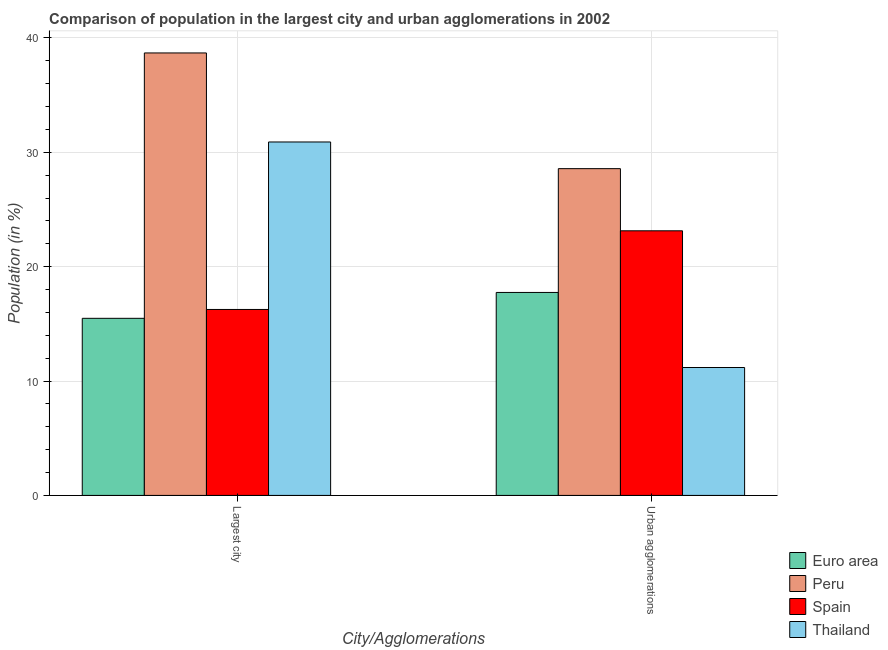How many groups of bars are there?
Offer a very short reply. 2. Are the number of bars per tick equal to the number of legend labels?
Offer a terse response. Yes. How many bars are there on the 1st tick from the left?
Provide a short and direct response. 4. What is the label of the 1st group of bars from the left?
Ensure brevity in your answer.  Largest city. What is the population in urban agglomerations in Thailand?
Give a very brief answer. 11.18. Across all countries, what is the maximum population in the largest city?
Offer a terse response. 38.68. Across all countries, what is the minimum population in the largest city?
Offer a terse response. 15.48. In which country was the population in the largest city maximum?
Keep it short and to the point. Peru. In which country was the population in urban agglomerations minimum?
Offer a terse response. Thailand. What is the total population in urban agglomerations in the graph?
Offer a terse response. 80.63. What is the difference between the population in the largest city in Peru and that in Thailand?
Provide a short and direct response. 7.78. What is the difference between the population in the largest city in Peru and the population in urban agglomerations in Euro area?
Give a very brief answer. 20.94. What is the average population in urban agglomerations per country?
Your answer should be very brief. 20.16. What is the difference between the population in urban agglomerations and population in the largest city in Euro area?
Provide a short and direct response. 2.26. In how many countries, is the population in urban agglomerations greater than 4 %?
Your answer should be very brief. 4. What is the ratio of the population in urban agglomerations in Peru to that in Spain?
Provide a short and direct response. 1.23. In how many countries, is the population in the largest city greater than the average population in the largest city taken over all countries?
Ensure brevity in your answer.  2. How many bars are there?
Make the answer very short. 8. Are the values on the major ticks of Y-axis written in scientific E-notation?
Provide a short and direct response. No. Does the graph contain any zero values?
Your answer should be very brief. No. How many legend labels are there?
Offer a terse response. 4. What is the title of the graph?
Your answer should be compact. Comparison of population in the largest city and urban agglomerations in 2002. Does "Oman" appear as one of the legend labels in the graph?
Offer a terse response. No. What is the label or title of the X-axis?
Your response must be concise. City/Agglomerations. What is the label or title of the Y-axis?
Keep it short and to the point. Population (in %). What is the Population (in %) of Euro area in Largest city?
Make the answer very short. 15.48. What is the Population (in %) of Peru in Largest city?
Ensure brevity in your answer.  38.68. What is the Population (in %) in Spain in Largest city?
Ensure brevity in your answer.  16.26. What is the Population (in %) of Thailand in Largest city?
Your response must be concise. 30.9. What is the Population (in %) in Euro area in Urban agglomerations?
Your response must be concise. 17.74. What is the Population (in %) in Peru in Urban agglomerations?
Keep it short and to the point. 28.57. What is the Population (in %) of Spain in Urban agglomerations?
Make the answer very short. 23.13. What is the Population (in %) of Thailand in Urban agglomerations?
Your response must be concise. 11.18. Across all City/Agglomerations, what is the maximum Population (in %) in Euro area?
Offer a terse response. 17.74. Across all City/Agglomerations, what is the maximum Population (in %) in Peru?
Ensure brevity in your answer.  38.68. Across all City/Agglomerations, what is the maximum Population (in %) in Spain?
Your answer should be compact. 23.13. Across all City/Agglomerations, what is the maximum Population (in %) of Thailand?
Offer a terse response. 30.9. Across all City/Agglomerations, what is the minimum Population (in %) in Euro area?
Offer a very short reply. 15.48. Across all City/Agglomerations, what is the minimum Population (in %) in Peru?
Your answer should be very brief. 28.57. Across all City/Agglomerations, what is the minimum Population (in %) in Spain?
Make the answer very short. 16.26. Across all City/Agglomerations, what is the minimum Population (in %) in Thailand?
Provide a short and direct response. 11.18. What is the total Population (in %) of Euro area in the graph?
Ensure brevity in your answer.  33.23. What is the total Population (in %) of Peru in the graph?
Offer a very short reply. 67.25. What is the total Population (in %) in Spain in the graph?
Provide a short and direct response. 39.39. What is the total Population (in %) of Thailand in the graph?
Offer a very short reply. 42.08. What is the difference between the Population (in %) in Euro area in Largest city and that in Urban agglomerations?
Offer a very short reply. -2.26. What is the difference between the Population (in %) in Peru in Largest city and that in Urban agglomerations?
Make the answer very short. 10.11. What is the difference between the Population (in %) of Spain in Largest city and that in Urban agglomerations?
Make the answer very short. -6.88. What is the difference between the Population (in %) of Thailand in Largest city and that in Urban agglomerations?
Your answer should be very brief. 19.72. What is the difference between the Population (in %) of Euro area in Largest city and the Population (in %) of Peru in Urban agglomerations?
Provide a short and direct response. -13.08. What is the difference between the Population (in %) of Euro area in Largest city and the Population (in %) of Spain in Urban agglomerations?
Make the answer very short. -7.65. What is the difference between the Population (in %) of Euro area in Largest city and the Population (in %) of Thailand in Urban agglomerations?
Make the answer very short. 4.3. What is the difference between the Population (in %) of Peru in Largest city and the Population (in %) of Spain in Urban agglomerations?
Provide a short and direct response. 15.55. What is the difference between the Population (in %) in Peru in Largest city and the Population (in %) in Thailand in Urban agglomerations?
Offer a very short reply. 27.5. What is the difference between the Population (in %) of Spain in Largest city and the Population (in %) of Thailand in Urban agglomerations?
Your answer should be compact. 5.07. What is the average Population (in %) of Euro area per City/Agglomerations?
Your answer should be very brief. 16.61. What is the average Population (in %) of Peru per City/Agglomerations?
Provide a short and direct response. 33.62. What is the average Population (in %) in Spain per City/Agglomerations?
Keep it short and to the point. 19.69. What is the average Population (in %) of Thailand per City/Agglomerations?
Your response must be concise. 21.04. What is the difference between the Population (in %) in Euro area and Population (in %) in Peru in Largest city?
Give a very brief answer. -23.2. What is the difference between the Population (in %) in Euro area and Population (in %) in Spain in Largest city?
Give a very brief answer. -0.77. What is the difference between the Population (in %) in Euro area and Population (in %) in Thailand in Largest city?
Provide a succinct answer. -15.42. What is the difference between the Population (in %) in Peru and Population (in %) in Spain in Largest city?
Your answer should be compact. 22.42. What is the difference between the Population (in %) of Peru and Population (in %) of Thailand in Largest city?
Give a very brief answer. 7.78. What is the difference between the Population (in %) of Spain and Population (in %) of Thailand in Largest city?
Your response must be concise. -14.64. What is the difference between the Population (in %) in Euro area and Population (in %) in Peru in Urban agglomerations?
Keep it short and to the point. -10.82. What is the difference between the Population (in %) in Euro area and Population (in %) in Spain in Urban agglomerations?
Your response must be concise. -5.39. What is the difference between the Population (in %) of Euro area and Population (in %) of Thailand in Urban agglomerations?
Provide a short and direct response. 6.56. What is the difference between the Population (in %) in Peru and Population (in %) in Spain in Urban agglomerations?
Your answer should be very brief. 5.43. What is the difference between the Population (in %) of Peru and Population (in %) of Thailand in Urban agglomerations?
Provide a succinct answer. 17.38. What is the difference between the Population (in %) in Spain and Population (in %) in Thailand in Urban agglomerations?
Offer a very short reply. 11.95. What is the ratio of the Population (in %) in Euro area in Largest city to that in Urban agglomerations?
Your answer should be very brief. 0.87. What is the ratio of the Population (in %) in Peru in Largest city to that in Urban agglomerations?
Make the answer very short. 1.35. What is the ratio of the Population (in %) in Spain in Largest city to that in Urban agglomerations?
Provide a short and direct response. 0.7. What is the ratio of the Population (in %) of Thailand in Largest city to that in Urban agglomerations?
Offer a terse response. 2.76. What is the difference between the highest and the second highest Population (in %) of Euro area?
Ensure brevity in your answer.  2.26. What is the difference between the highest and the second highest Population (in %) in Peru?
Keep it short and to the point. 10.11. What is the difference between the highest and the second highest Population (in %) in Spain?
Offer a terse response. 6.88. What is the difference between the highest and the second highest Population (in %) in Thailand?
Ensure brevity in your answer.  19.72. What is the difference between the highest and the lowest Population (in %) in Euro area?
Provide a succinct answer. 2.26. What is the difference between the highest and the lowest Population (in %) of Peru?
Your answer should be very brief. 10.11. What is the difference between the highest and the lowest Population (in %) of Spain?
Keep it short and to the point. 6.88. What is the difference between the highest and the lowest Population (in %) of Thailand?
Offer a very short reply. 19.72. 